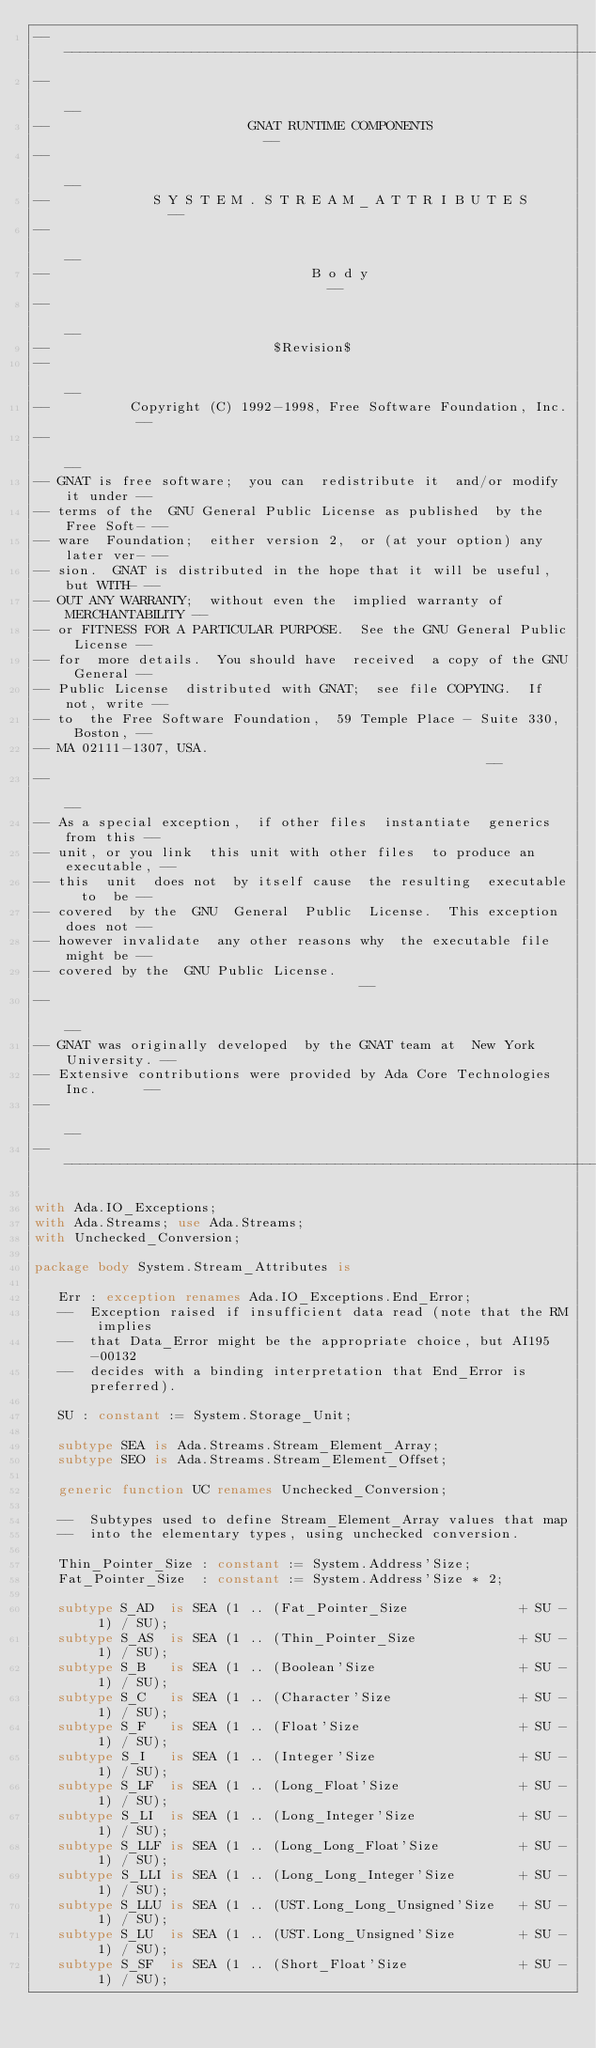<code> <loc_0><loc_0><loc_500><loc_500><_Ada_>------------------------------------------------------------------------------
--                                                                          --
--                         GNAT RUNTIME COMPONENTS                          --
--                                                                          --
--             S Y S T E M . S T R E A M _ A T T R I B U T E S              --
--                                                                          --
--                                 B o d y                                  --
--                                                                          --
--                            $Revision$
--                                                                          --
--          Copyright (C) 1992-1998, Free Software Foundation, Inc.         --
--                                                                          --
-- GNAT is free software;  you can  redistribute it  and/or modify it under --
-- terms of the  GNU General Public License as published  by the Free Soft- --
-- ware  Foundation;  either version 2,  or (at your option) any later ver- --
-- sion.  GNAT is distributed in the hope that it will be useful, but WITH- --
-- OUT ANY WARRANTY;  without even the  implied warranty of MERCHANTABILITY --
-- or FITNESS FOR A PARTICULAR PURPOSE.  See the GNU General Public License --
-- for  more details.  You should have  received  a copy of the GNU General --
-- Public License  distributed with GNAT;  see file COPYING.  If not, write --
-- to  the Free Software Foundation,  59 Temple Place - Suite 330,  Boston, --
-- MA 02111-1307, USA.                                                      --
--                                                                          --
-- As a special exception,  if other files  instantiate  generics from this --
-- unit, or you link  this unit with other files  to produce an executable, --
-- this  unit  does not  by itself cause  the resulting  executable  to  be --
-- covered  by the  GNU  General  Public  License.  This exception does not --
-- however invalidate  any other reasons why  the executable file  might be --
-- covered by the  GNU Public License.                                      --
--                                                                          --
-- GNAT was originally developed  by the GNAT team at  New York University. --
-- Extensive contributions were provided by Ada Core Technologies Inc.      --
--                                                                          --
------------------------------------------------------------------------------

with Ada.IO_Exceptions;
with Ada.Streams; use Ada.Streams;
with Unchecked_Conversion;

package body System.Stream_Attributes is

   Err : exception renames Ada.IO_Exceptions.End_Error;
   --  Exception raised if insufficient data read (note that the RM implies
   --  that Data_Error might be the appropriate choice, but AI195-00132
   --  decides with a binding interpretation that End_Error is preferred).

   SU : constant := System.Storage_Unit;

   subtype SEA is Ada.Streams.Stream_Element_Array;
   subtype SEO is Ada.Streams.Stream_Element_Offset;

   generic function UC renames Unchecked_Conversion;

   --  Subtypes used to define Stream_Element_Array values that map
   --  into the elementary types, using unchecked conversion.

   Thin_Pointer_Size : constant := System.Address'Size;
   Fat_Pointer_Size  : constant := System.Address'Size * 2;

   subtype S_AD  is SEA (1 .. (Fat_Pointer_Size              + SU - 1) / SU);
   subtype S_AS  is SEA (1 .. (Thin_Pointer_Size             + SU - 1) / SU);
   subtype S_B   is SEA (1 .. (Boolean'Size                  + SU - 1) / SU);
   subtype S_C   is SEA (1 .. (Character'Size                + SU - 1) / SU);
   subtype S_F   is SEA (1 .. (Float'Size                    + SU - 1) / SU);
   subtype S_I   is SEA (1 .. (Integer'Size                  + SU - 1) / SU);
   subtype S_LF  is SEA (1 .. (Long_Float'Size               + SU - 1) / SU);
   subtype S_LI  is SEA (1 .. (Long_Integer'Size             + SU - 1) / SU);
   subtype S_LLF is SEA (1 .. (Long_Long_Float'Size          + SU - 1) / SU);
   subtype S_LLI is SEA (1 .. (Long_Long_Integer'Size        + SU - 1) / SU);
   subtype S_LLU is SEA (1 .. (UST.Long_Long_Unsigned'Size   + SU - 1) / SU);
   subtype S_LU  is SEA (1 .. (UST.Long_Unsigned'Size        + SU - 1) / SU);
   subtype S_SF  is SEA (1 .. (Short_Float'Size              + SU - 1) / SU);</code> 